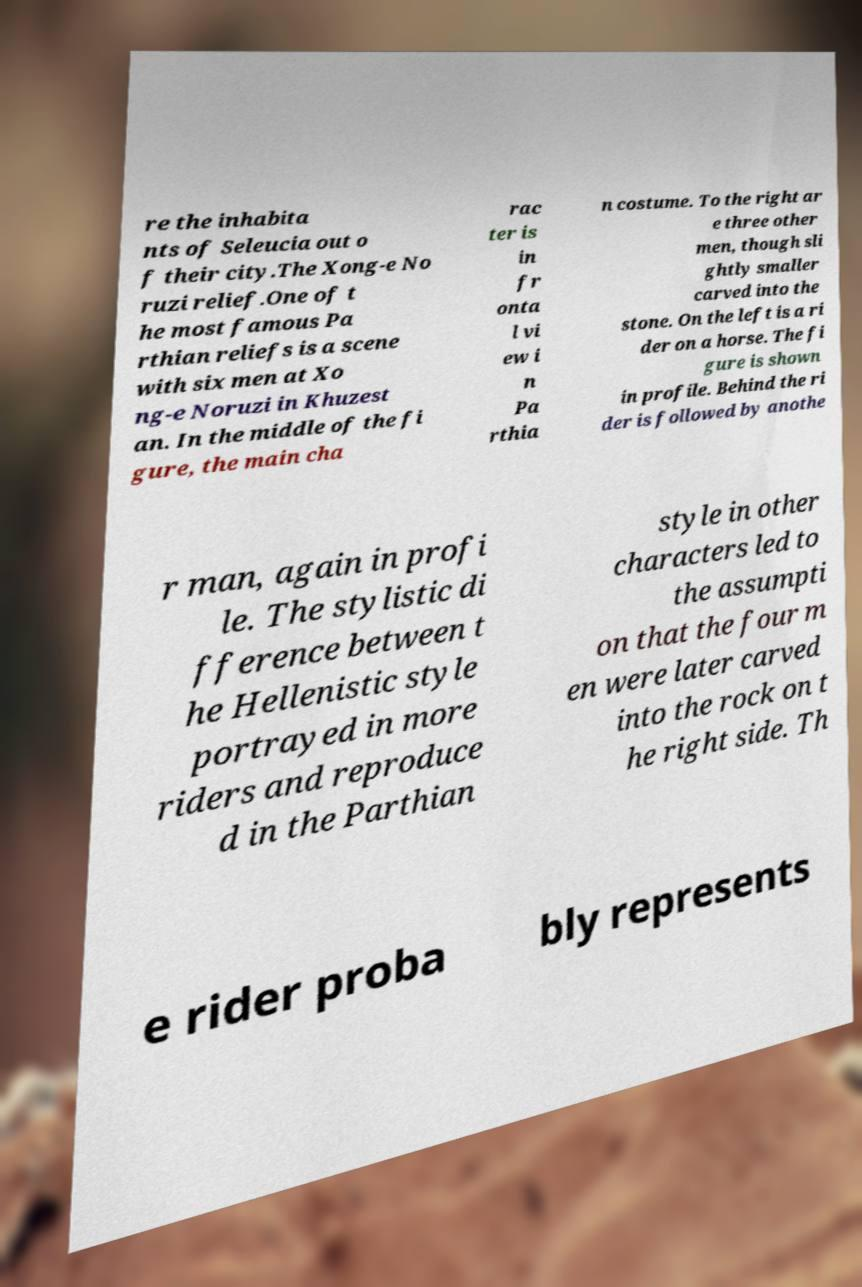What messages or text are displayed in this image? I need them in a readable, typed format. re the inhabita nts of Seleucia out o f their city.The Xong-e No ruzi relief.One of t he most famous Pa rthian reliefs is a scene with six men at Xo ng-e Noruzi in Khuzest an. In the middle of the fi gure, the main cha rac ter is in fr onta l vi ew i n Pa rthia n costume. To the right ar e three other men, though sli ghtly smaller carved into the stone. On the left is a ri der on a horse. The fi gure is shown in profile. Behind the ri der is followed by anothe r man, again in profi le. The stylistic di fference between t he Hellenistic style portrayed in more riders and reproduce d in the Parthian style in other characters led to the assumpti on that the four m en were later carved into the rock on t he right side. Th e rider proba bly represents 